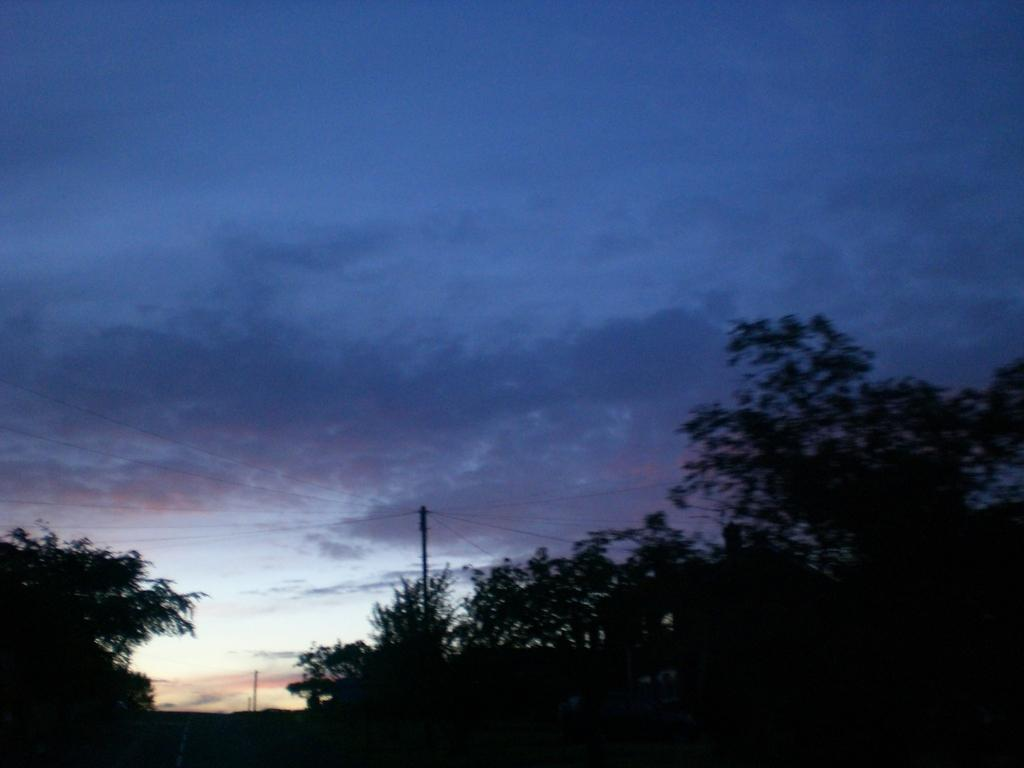What type of vegetation is at the bottom of the image? There are many trees at the bottom of the image. What is the lighting condition for the trees in the image? The trees are in the dark. What structures can be seen in the image besides the trees? There are poles along with wires in the image. What is visible at the top of the image? The sky is visible at the top of the image. What can be observed in the sky? Clouds are present in the sky. What is the argument about between the trees in the image? There is no argument present in the image; it is a visual representation of trees, poles, wires, and the sky. 